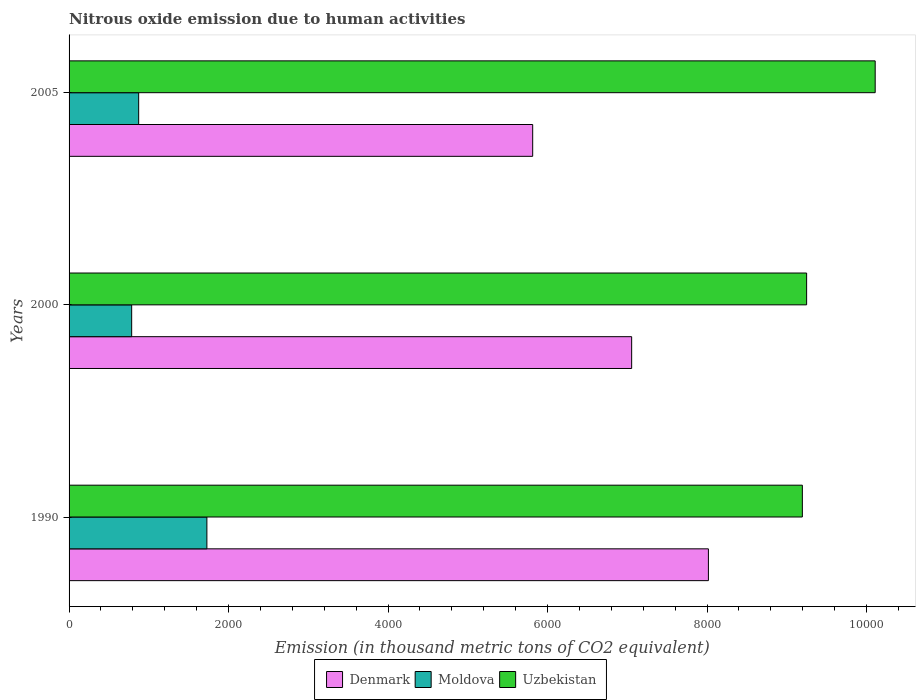How many groups of bars are there?
Your response must be concise. 3. In how many cases, is the number of bars for a given year not equal to the number of legend labels?
Offer a very short reply. 0. What is the amount of nitrous oxide emitted in Uzbekistan in 2005?
Offer a terse response. 1.01e+04. Across all years, what is the maximum amount of nitrous oxide emitted in Uzbekistan?
Give a very brief answer. 1.01e+04. Across all years, what is the minimum amount of nitrous oxide emitted in Moldova?
Keep it short and to the point. 785. In which year was the amount of nitrous oxide emitted in Moldova maximum?
Provide a succinct answer. 1990. In which year was the amount of nitrous oxide emitted in Uzbekistan minimum?
Your response must be concise. 1990. What is the total amount of nitrous oxide emitted in Denmark in the graph?
Your answer should be very brief. 2.09e+04. What is the difference between the amount of nitrous oxide emitted in Denmark in 1990 and that in 2000?
Make the answer very short. 962.5. What is the difference between the amount of nitrous oxide emitted in Denmark in 1990 and the amount of nitrous oxide emitted in Moldova in 2000?
Make the answer very short. 7232.4. What is the average amount of nitrous oxide emitted in Denmark per year?
Give a very brief answer. 6962.07. In the year 2000, what is the difference between the amount of nitrous oxide emitted in Denmark and amount of nitrous oxide emitted in Moldova?
Give a very brief answer. 6269.9. What is the ratio of the amount of nitrous oxide emitted in Moldova in 2000 to that in 2005?
Ensure brevity in your answer.  0.9. What is the difference between the highest and the second highest amount of nitrous oxide emitted in Denmark?
Provide a succinct answer. 962.5. What is the difference between the highest and the lowest amount of nitrous oxide emitted in Uzbekistan?
Ensure brevity in your answer.  913.2. In how many years, is the amount of nitrous oxide emitted in Moldova greater than the average amount of nitrous oxide emitted in Moldova taken over all years?
Provide a succinct answer. 1. What does the 3rd bar from the top in 1990 represents?
Give a very brief answer. Denmark. What does the 1st bar from the bottom in 2005 represents?
Make the answer very short. Denmark. Is it the case that in every year, the sum of the amount of nitrous oxide emitted in Denmark and amount of nitrous oxide emitted in Uzbekistan is greater than the amount of nitrous oxide emitted in Moldova?
Make the answer very short. Yes. How many bars are there?
Offer a very short reply. 9. Are all the bars in the graph horizontal?
Your answer should be compact. Yes. Are the values on the major ticks of X-axis written in scientific E-notation?
Offer a terse response. No. Does the graph contain any zero values?
Your response must be concise. No. Does the graph contain grids?
Provide a succinct answer. No. Where does the legend appear in the graph?
Keep it short and to the point. Bottom center. How many legend labels are there?
Ensure brevity in your answer.  3. How are the legend labels stacked?
Provide a short and direct response. Horizontal. What is the title of the graph?
Keep it short and to the point. Nitrous oxide emission due to human activities. What is the label or title of the X-axis?
Your answer should be compact. Emission (in thousand metric tons of CO2 equivalent). What is the label or title of the Y-axis?
Your answer should be compact. Years. What is the Emission (in thousand metric tons of CO2 equivalent) in Denmark in 1990?
Keep it short and to the point. 8017.4. What is the Emission (in thousand metric tons of CO2 equivalent) in Moldova in 1990?
Your answer should be very brief. 1728.3. What is the Emission (in thousand metric tons of CO2 equivalent) of Uzbekistan in 1990?
Ensure brevity in your answer.  9195.7. What is the Emission (in thousand metric tons of CO2 equivalent) in Denmark in 2000?
Your response must be concise. 7054.9. What is the Emission (in thousand metric tons of CO2 equivalent) in Moldova in 2000?
Offer a very short reply. 785. What is the Emission (in thousand metric tons of CO2 equivalent) of Uzbekistan in 2000?
Offer a very short reply. 9249.1. What is the Emission (in thousand metric tons of CO2 equivalent) of Denmark in 2005?
Offer a very short reply. 5813.9. What is the Emission (in thousand metric tons of CO2 equivalent) of Moldova in 2005?
Offer a terse response. 872.9. What is the Emission (in thousand metric tons of CO2 equivalent) of Uzbekistan in 2005?
Ensure brevity in your answer.  1.01e+04. Across all years, what is the maximum Emission (in thousand metric tons of CO2 equivalent) of Denmark?
Your response must be concise. 8017.4. Across all years, what is the maximum Emission (in thousand metric tons of CO2 equivalent) in Moldova?
Offer a terse response. 1728.3. Across all years, what is the maximum Emission (in thousand metric tons of CO2 equivalent) of Uzbekistan?
Your answer should be very brief. 1.01e+04. Across all years, what is the minimum Emission (in thousand metric tons of CO2 equivalent) in Denmark?
Offer a terse response. 5813.9. Across all years, what is the minimum Emission (in thousand metric tons of CO2 equivalent) in Moldova?
Provide a short and direct response. 785. Across all years, what is the minimum Emission (in thousand metric tons of CO2 equivalent) of Uzbekistan?
Your response must be concise. 9195.7. What is the total Emission (in thousand metric tons of CO2 equivalent) in Denmark in the graph?
Your answer should be compact. 2.09e+04. What is the total Emission (in thousand metric tons of CO2 equivalent) in Moldova in the graph?
Give a very brief answer. 3386.2. What is the total Emission (in thousand metric tons of CO2 equivalent) of Uzbekistan in the graph?
Offer a terse response. 2.86e+04. What is the difference between the Emission (in thousand metric tons of CO2 equivalent) of Denmark in 1990 and that in 2000?
Your answer should be very brief. 962.5. What is the difference between the Emission (in thousand metric tons of CO2 equivalent) in Moldova in 1990 and that in 2000?
Provide a short and direct response. 943.3. What is the difference between the Emission (in thousand metric tons of CO2 equivalent) in Uzbekistan in 1990 and that in 2000?
Keep it short and to the point. -53.4. What is the difference between the Emission (in thousand metric tons of CO2 equivalent) of Denmark in 1990 and that in 2005?
Provide a short and direct response. 2203.5. What is the difference between the Emission (in thousand metric tons of CO2 equivalent) of Moldova in 1990 and that in 2005?
Offer a very short reply. 855.4. What is the difference between the Emission (in thousand metric tons of CO2 equivalent) of Uzbekistan in 1990 and that in 2005?
Provide a short and direct response. -913.2. What is the difference between the Emission (in thousand metric tons of CO2 equivalent) of Denmark in 2000 and that in 2005?
Your response must be concise. 1241. What is the difference between the Emission (in thousand metric tons of CO2 equivalent) of Moldova in 2000 and that in 2005?
Make the answer very short. -87.9. What is the difference between the Emission (in thousand metric tons of CO2 equivalent) in Uzbekistan in 2000 and that in 2005?
Your response must be concise. -859.8. What is the difference between the Emission (in thousand metric tons of CO2 equivalent) of Denmark in 1990 and the Emission (in thousand metric tons of CO2 equivalent) of Moldova in 2000?
Your answer should be compact. 7232.4. What is the difference between the Emission (in thousand metric tons of CO2 equivalent) in Denmark in 1990 and the Emission (in thousand metric tons of CO2 equivalent) in Uzbekistan in 2000?
Your response must be concise. -1231.7. What is the difference between the Emission (in thousand metric tons of CO2 equivalent) of Moldova in 1990 and the Emission (in thousand metric tons of CO2 equivalent) of Uzbekistan in 2000?
Ensure brevity in your answer.  -7520.8. What is the difference between the Emission (in thousand metric tons of CO2 equivalent) of Denmark in 1990 and the Emission (in thousand metric tons of CO2 equivalent) of Moldova in 2005?
Your response must be concise. 7144.5. What is the difference between the Emission (in thousand metric tons of CO2 equivalent) in Denmark in 1990 and the Emission (in thousand metric tons of CO2 equivalent) in Uzbekistan in 2005?
Offer a very short reply. -2091.5. What is the difference between the Emission (in thousand metric tons of CO2 equivalent) of Moldova in 1990 and the Emission (in thousand metric tons of CO2 equivalent) of Uzbekistan in 2005?
Offer a very short reply. -8380.6. What is the difference between the Emission (in thousand metric tons of CO2 equivalent) of Denmark in 2000 and the Emission (in thousand metric tons of CO2 equivalent) of Moldova in 2005?
Your response must be concise. 6182. What is the difference between the Emission (in thousand metric tons of CO2 equivalent) of Denmark in 2000 and the Emission (in thousand metric tons of CO2 equivalent) of Uzbekistan in 2005?
Keep it short and to the point. -3054. What is the difference between the Emission (in thousand metric tons of CO2 equivalent) of Moldova in 2000 and the Emission (in thousand metric tons of CO2 equivalent) of Uzbekistan in 2005?
Provide a short and direct response. -9323.9. What is the average Emission (in thousand metric tons of CO2 equivalent) in Denmark per year?
Your answer should be very brief. 6962.07. What is the average Emission (in thousand metric tons of CO2 equivalent) in Moldova per year?
Provide a short and direct response. 1128.73. What is the average Emission (in thousand metric tons of CO2 equivalent) of Uzbekistan per year?
Your answer should be compact. 9517.9. In the year 1990, what is the difference between the Emission (in thousand metric tons of CO2 equivalent) in Denmark and Emission (in thousand metric tons of CO2 equivalent) in Moldova?
Provide a short and direct response. 6289.1. In the year 1990, what is the difference between the Emission (in thousand metric tons of CO2 equivalent) in Denmark and Emission (in thousand metric tons of CO2 equivalent) in Uzbekistan?
Your response must be concise. -1178.3. In the year 1990, what is the difference between the Emission (in thousand metric tons of CO2 equivalent) in Moldova and Emission (in thousand metric tons of CO2 equivalent) in Uzbekistan?
Offer a very short reply. -7467.4. In the year 2000, what is the difference between the Emission (in thousand metric tons of CO2 equivalent) in Denmark and Emission (in thousand metric tons of CO2 equivalent) in Moldova?
Your answer should be compact. 6269.9. In the year 2000, what is the difference between the Emission (in thousand metric tons of CO2 equivalent) in Denmark and Emission (in thousand metric tons of CO2 equivalent) in Uzbekistan?
Provide a short and direct response. -2194.2. In the year 2000, what is the difference between the Emission (in thousand metric tons of CO2 equivalent) of Moldova and Emission (in thousand metric tons of CO2 equivalent) of Uzbekistan?
Your answer should be compact. -8464.1. In the year 2005, what is the difference between the Emission (in thousand metric tons of CO2 equivalent) in Denmark and Emission (in thousand metric tons of CO2 equivalent) in Moldova?
Offer a very short reply. 4941. In the year 2005, what is the difference between the Emission (in thousand metric tons of CO2 equivalent) in Denmark and Emission (in thousand metric tons of CO2 equivalent) in Uzbekistan?
Make the answer very short. -4295. In the year 2005, what is the difference between the Emission (in thousand metric tons of CO2 equivalent) in Moldova and Emission (in thousand metric tons of CO2 equivalent) in Uzbekistan?
Offer a very short reply. -9236. What is the ratio of the Emission (in thousand metric tons of CO2 equivalent) of Denmark in 1990 to that in 2000?
Provide a succinct answer. 1.14. What is the ratio of the Emission (in thousand metric tons of CO2 equivalent) in Moldova in 1990 to that in 2000?
Provide a short and direct response. 2.2. What is the ratio of the Emission (in thousand metric tons of CO2 equivalent) in Denmark in 1990 to that in 2005?
Ensure brevity in your answer.  1.38. What is the ratio of the Emission (in thousand metric tons of CO2 equivalent) in Moldova in 1990 to that in 2005?
Make the answer very short. 1.98. What is the ratio of the Emission (in thousand metric tons of CO2 equivalent) of Uzbekistan in 1990 to that in 2005?
Keep it short and to the point. 0.91. What is the ratio of the Emission (in thousand metric tons of CO2 equivalent) in Denmark in 2000 to that in 2005?
Provide a succinct answer. 1.21. What is the ratio of the Emission (in thousand metric tons of CO2 equivalent) in Moldova in 2000 to that in 2005?
Keep it short and to the point. 0.9. What is the ratio of the Emission (in thousand metric tons of CO2 equivalent) in Uzbekistan in 2000 to that in 2005?
Your response must be concise. 0.91. What is the difference between the highest and the second highest Emission (in thousand metric tons of CO2 equivalent) of Denmark?
Make the answer very short. 962.5. What is the difference between the highest and the second highest Emission (in thousand metric tons of CO2 equivalent) in Moldova?
Your answer should be very brief. 855.4. What is the difference between the highest and the second highest Emission (in thousand metric tons of CO2 equivalent) of Uzbekistan?
Provide a succinct answer. 859.8. What is the difference between the highest and the lowest Emission (in thousand metric tons of CO2 equivalent) of Denmark?
Keep it short and to the point. 2203.5. What is the difference between the highest and the lowest Emission (in thousand metric tons of CO2 equivalent) in Moldova?
Provide a short and direct response. 943.3. What is the difference between the highest and the lowest Emission (in thousand metric tons of CO2 equivalent) of Uzbekistan?
Offer a very short reply. 913.2. 